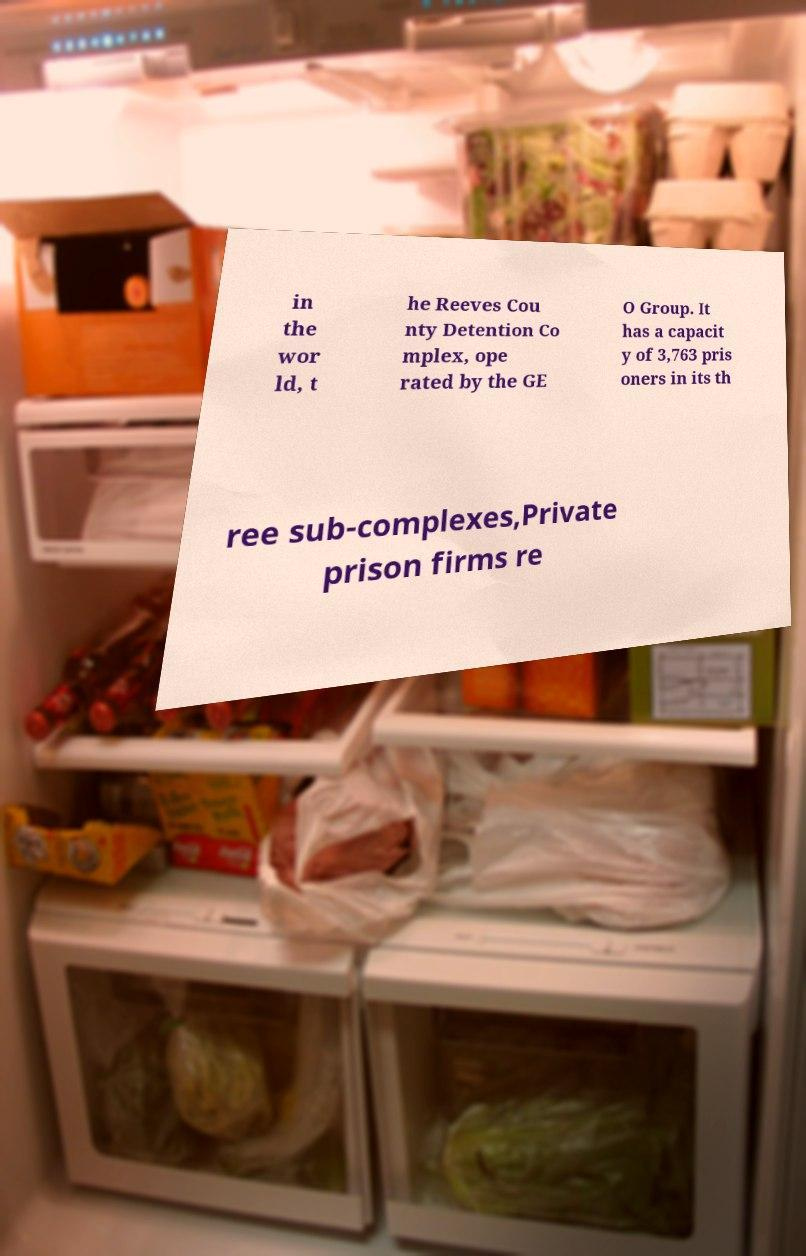Can you accurately transcribe the text from the provided image for me? in the wor ld, t he Reeves Cou nty Detention Co mplex, ope rated by the GE O Group. It has a capacit y of 3,763 pris oners in its th ree sub-complexes,Private prison firms re 